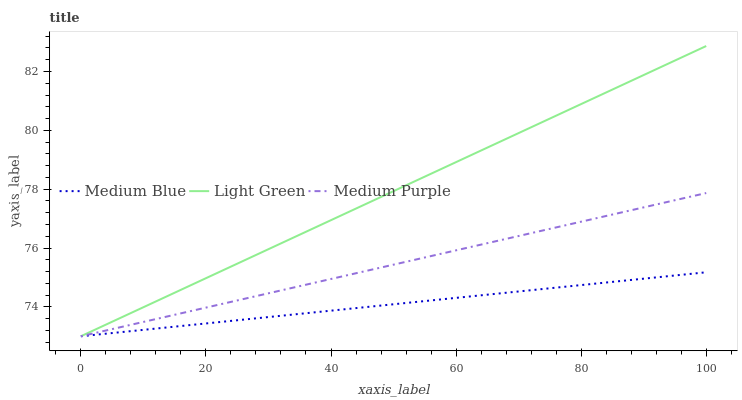Does Medium Blue have the minimum area under the curve?
Answer yes or no. Yes. Does Light Green have the maximum area under the curve?
Answer yes or no. Yes. Does Light Green have the minimum area under the curve?
Answer yes or no. No. Does Medium Blue have the maximum area under the curve?
Answer yes or no. No. Is Medium Blue the smoothest?
Answer yes or no. Yes. Is Light Green the roughest?
Answer yes or no. Yes. Is Light Green the smoothest?
Answer yes or no. No. Is Medium Blue the roughest?
Answer yes or no. No. Does Medium Purple have the lowest value?
Answer yes or no. Yes. Does Light Green have the highest value?
Answer yes or no. Yes. Does Medium Blue have the highest value?
Answer yes or no. No. Does Medium Blue intersect Light Green?
Answer yes or no. Yes. Is Medium Blue less than Light Green?
Answer yes or no. No. Is Medium Blue greater than Light Green?
Answer yes or no. No. 